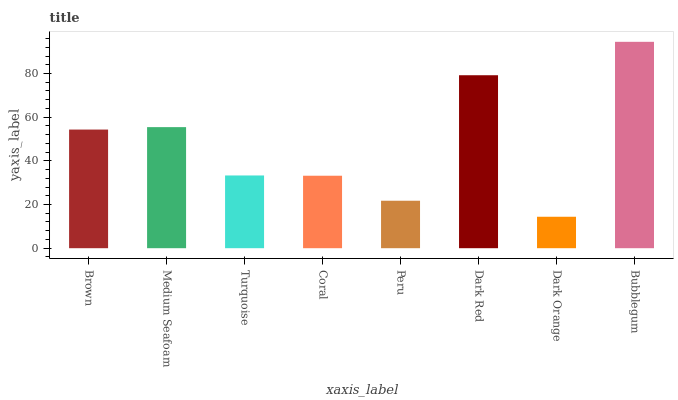Is Medium Seafoam the minimum?
Answer yes or no. No. Is Medium Seafoam the maximum?
Answer yes or no. No. Is Medium Seafoam greater than Brown?
Answer yes or no. Yes. Is Brown less than Medium Seafoam?
Answer yes or no. Yes. Is Brown greater than Medium Seafoam?
Answer yes or no. No. Is Medium Seafoam less than Brown?
Answer yes or no. No. Is Brown the high median?
Answer yes or no. Yes. Is Turquoise the low median?
Answer yes or no. Yes. Is Peru the high median?
Answer yes or no. No. Is Medium Seafoam the low median?
Answer yes or no. No. 